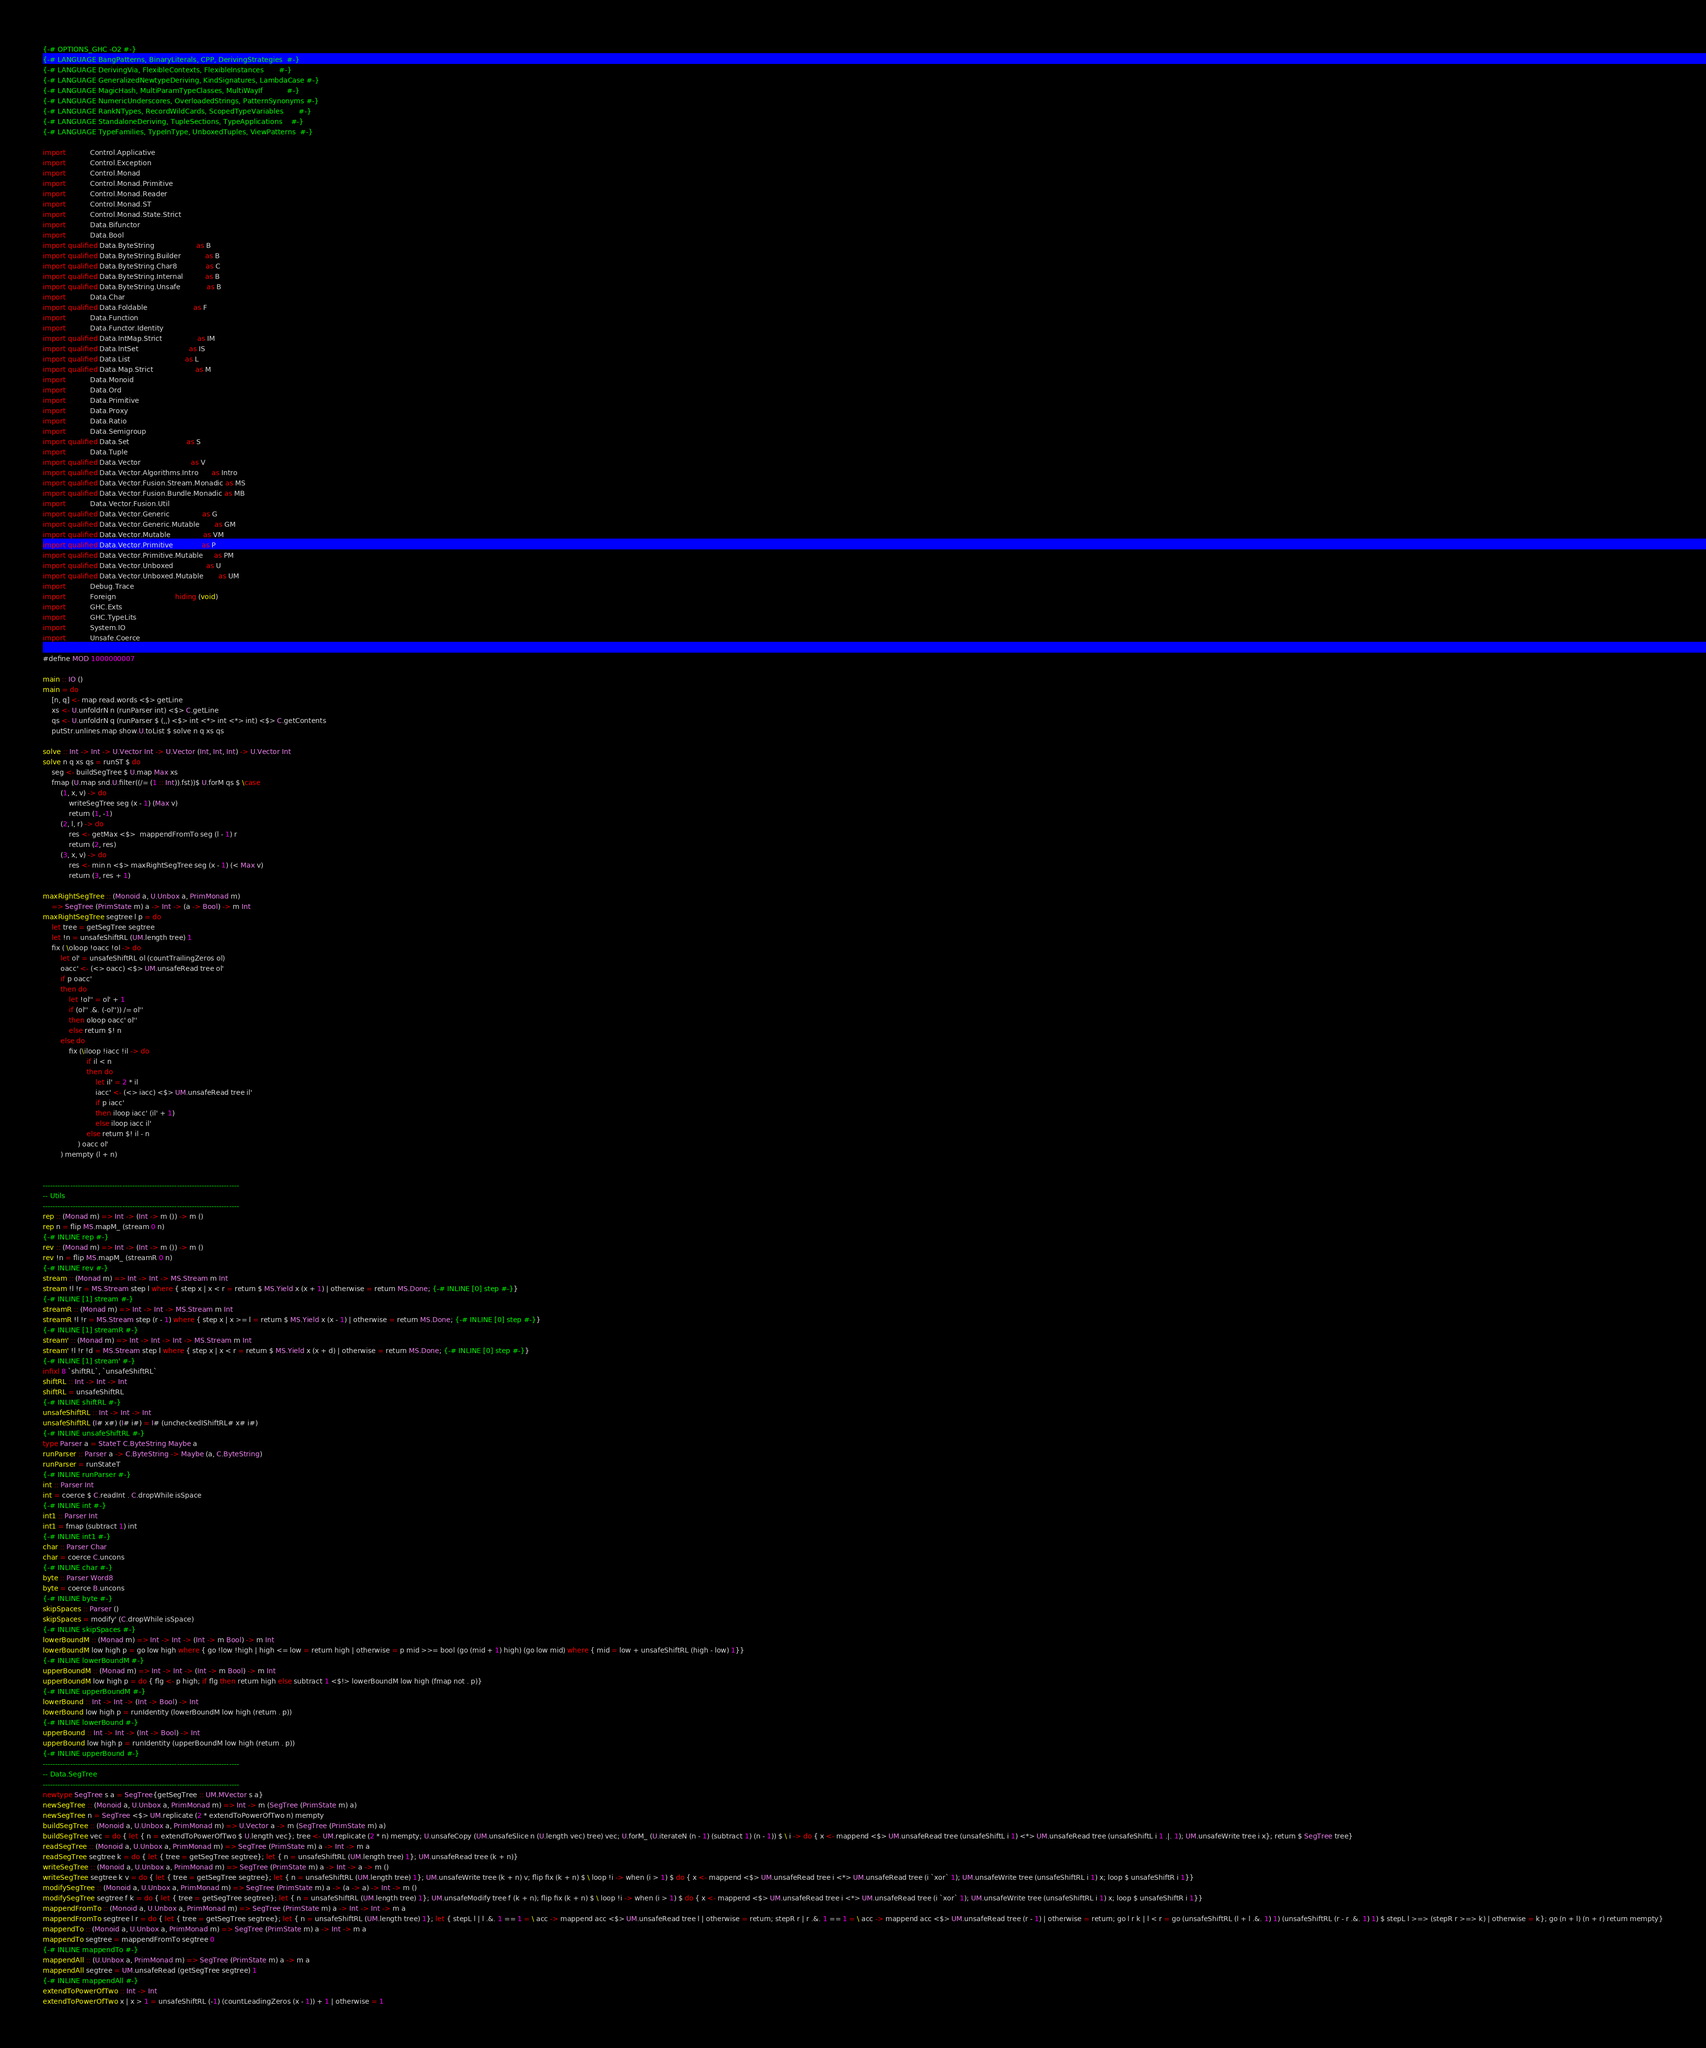Convert code to text. <code><loc_0><loc_0><loc_500><loc_500><_Haskell_>{-# OPTIONS_GHC -O2 #-}
{-# LANGUAGE BangPatterns, BinaryLiterals, CPP, DerivingStrategies  #-}
{-# LANGUAGE DerivingVia, FlexibleContexts, FlexibleInstances       #-}
{-# LANGUAGE GeneralizedNewtypeDeriving, KindSignatures, LambdaCase #-}
{-# LANGUAGE MagicHash, MultiParamTypeClasses, MultiWayIf           #-}
{-# LANGUAGE NumericUnderscores, OverloadedStrings, PatternSynonyms #-}
{-# LANGUAGE RankNTypes, RecordWildCards, ScopedTypeVariables       #-}
{-# LANGUAGE StandaloneDeriving, TupleSections, TypeApplications    #-}
{-# LANGUAGE TypeFamilies, TypeInType, UnboxedTuples, ViewPatterns  #-}

import           Control.Applicative
import           Control.Exception
import           Control.Monad
import           Control.Monad.Primitive
import           Control.Monad.Reader
import           Control.Monad.ST
import           Control.Monad.State.Strict
import           Data.Bifunctor
import           Data.Bool
import qualified Data.ByteString                   as B
import qualified Data.ByteString.Builder           as B
import qualified Data.ByteString.Char8             as C
import qualified Data.ByteString.Internal          as B
import qualified Data.ByteString.Unsafe            as B
import           Data.Char
import qualified Data.Foldable                     as F
import           Data.Function
import           Data.Functor.Identity
import qualified Data.IntMap.Strict                as IM
import qualified Data.IntSet                       as IS
import qualified Data.List                         as L
import qualified Data.Map.Strict                   as M
import           Data.Monoid
import           Data.Ord
import           Data.Primitive
import           Data.Proxy
import           Data.Ratio
import           Data.Semigroup
import qualified Data.Set                          as S
import           Data.Tuple
import qualified Data.Vector                       as V
import qualified Data.Vector.Algorithms.Intro      as Intro
import qualified Data.Vector.Fusion.Stream.Monadic as MS
import qualified Data.Vector.Fusion.Bundle.Monadic as MB
import           Data.Vector.Fusion.Util
import qualified Data.Vector.Generic               as G
import qualified Data.Vector.Generic.Mutable       as GM
import qualified Data.Vector.Mutable               as VM
import qualified Data.Vector.Primitive             as P
import qualified Data.Vector.Primitive.Mutable     as PM
import qualified Data.Vector.Unboxed               as U
import qualified Data.Vector.Unboxed.Mutable       as UM
import           Debug.Trace
import           Foreign                           hiding (void)
import           GHC.Exts
import           GHC.TypeLits
import           System.IO
import           Unsafe.Coerce

#define MOD 1000000007

main :: IO ()
main = do
    [n, q] <- map read.words <$> getLine
    xs <- U.unfoldrN n (runParser int) <$> C.getLine
    qs <- U.unfoldrN q (runParser $ (,,) <$> int <*> int <*> int) <$> C.getContents
    putStr.unlines.map show.U.toList $ solve n q xs qs

solve :: Int -> Int -> U.Vector Int -> U.Vector (Int, Int, Int) -> U.Vector Int
solve n q xs qs = runST $ do
    seg <- buildSegTree $ U.map Max xs
    fmap (U.map snd.U.filter((/= (1 :: Int)).fst))$ U.forM qs $ \case
        (1, x, v) -> do
            writeSegTree seg (x - 1) (Max v)
            return (1, -1)
        (2, l, r) -> do
            res <- getMax <$>  mappendFromTo seg (l - 1) r
            return (2, res)
        (3, x, v) -> do
            res <- min n <$> maxRightSegTree seg (x - 1) (< Max v)
            return (3, res + 1)

maxRightSegTree :: (Monoid a, U.Unbox a, PrimMonad m)
    => SegTree (PrimState m) a -> Int -> (a -> Bool) -> m Int
maxRightSegTree segtree l p = do
    let tree = getSegTree segtree
    let !n = unsafeShiftRL (UM.length tree) 1
    fix ( \oloop !oacc !ol -> do
        let ol' = unsafeShiftRL ol (countTrailingZeros ol)
        oacc' <- (<> oacc) <$> UM.unsafeRead tree ol'
        if p oacc'
        then do
            let !ol'' = ol' + 1
            if (ol'' .&. (-ol'')) /= ol''
            then oloop oacc' ol''
            else return $! n
        else do
            fix (\iloop !iacc !il -> do
                    if il < n
                    then do
                        let il' = 2 * il
                        iacc' <- (<> iacc) <$> UM.unsafeRead tree il'
                        if p iacc'
                        then iloop iacc' (il' + 1)
                        else iloop iacc il'
                    else return $! il - n
                ) oacc ol'
        ) mempty (l + n)


-------------------------------------------------------------------------------
-- Utils
-------------------------------------------------------------------------------
rep :: (Monad m) => Int -> (Int -> m ()) -> m ()
rep n = flip MS.mapM_ (stream 0 n)
{-# INLINE rep #-}
rev :: (Monad m) => Int -> (Int -> m ()) -> m ()
rev !n = flip MS.mapM_ (streamR 0 n)
{-# INLINE rev #-}
stream :: (Monad m) => Int -> Int -> MS.Stream m Int
stream !l !r = MS.Stream step l where { step x | x < r = return $ MS.Yield x (x + 1) | otherwise = return MS.Done; {-# INLINE [0] step #-}}
{-# INLINE [1] stream #-}
streamR :: (Monad m) => Int -> Int -> MS.Stream m Int
streamR !l !r = MS.Stream step (r - 1) where { step x | x >= l = return $ MS.Yield x (x - 1) | otherwise = return MS.Done; {-# INLINE [0] step #-}}
{-# INLINE [1] streamR #-}
stream' :: (Monad m) => Int -> Int -> Int -> MS.Stream m Int
stream' !l !r !d = MS.Stream step l where { step x | x < r = return $ MS.Yield x (x + d) | otherwise = return MS.Done; {-# INLINE [0] step #-}}
{-# INLINE [1] stream' #-}
infixl 8 `shiftRL`, `unsafeShiftRL`
shiftRL :: Int -> Int -> Int
shiftRL = unsafeShiftRL
{-# INLINE shiftRL #-}
unsafeShiftRL :: Int -> Int -> Int
unsafeShiftRL (I# x#) (I# i#) = I# (uncheckedIShiftRL# x# i#)
{-# INLINE unsafeShiftRL #-}
type Parser a = StateT C.ByteString Maybe a
runParser :: Parser a -> C.ByteString -> Maybe (a, C.ByteString)
runParser = runStateT
{-# INLINE runParser #-}
int :: Parser Int
int = coerce $ C.readInt . C.dropWhile isSpace
{-# INLINE int #-}
int1 :: Parser Int
int1 = fmap (subtract 1) int
{-# INLINE int1 #-}
char :: Parser Char
char = coerce C.uncons
{-# INLINE char #-}
byte :: Parser Word8
byte = coerce B.uncons
{-# INLINE byte #-}
skipSpaces :: Parser ()
skipSpaces = modify' (C.dropWhile isSpace)
{-# INLINE skipSpaces #-}
lowerBoundM :: (Monad m) => Int -> Int -> (Int -> m Bool) -> m Int
lowerBoundM low high p = go low high where { go !low !high | high <= low = return high | otherwise = p mid >>= bool (go (mid + 1) high) (go low mid) where { mid = low + unsafeShiftRL (high - low) 1}}
{-# INLINE lowerBoundM #-}
upperBoundM :: (Monad m) => Int -> Int -> (Int -> m Bool) -> m Int
upperBoundM low high p = do { flg <- p high; if flg then return high else subtract 1 <$!> lowerBoundM low high (fmap not . p)}
{-# INLINE upperBoundM #-}
lowerBound :: Int -> Int -> (Int -> Bool) -> Int
lowerBound low high p = runIdentity (lowerBoundM low high (return . p))
{-# INLINE lowerBound #-}
upperBound :: Int -> Int -> (Int -> Bool) -> Int
upperBound low high p = runIdentity (upperBoundM low high (return . p))
{-# INLINE upperBound #-}
-------------------------------------------------------------------------------
-- Data.SegTree
-------------------------------------------------------------------------------
newtype SegTree s a = SegTree{getSegTree :: UM.MVector s a}
newSegTree :: (Monoid a, U.Unbox a, PrimMonad m) => Int -> m (SegTree (PrimState m) a)
newSegTree n = SegTree <$> UM.replicate (2 * extendToPowerOfTwo n) mempty
buildSegTree :: (Monoid a, U.Unbox a, PrimMonad m) => U.Vector a -> m (SegTree (PrimState m) a)
buildSegTree vec = do { let { n = extendToPowerOfTwo $ U.length vec}; tree <- UM.replicate (2 * n) mempty; U.unsafeCopy (UM.unsafeSlice n (U.length vec) tree) vec; U.forM_ (U.iterateN (n - 1) (subtract 1) (n - 1)) $ \ i -> do { x <- mappend <$> UM.unsafeRead tree (unsafeShiftL i 1) <*> UM.unsafeRead tree (unsafeShiftL i 1 .|. 1); UM.unsafeWrite tree i x}; return $ SegTree tree}
readSegTree :: (Monoid a, U.Unbox a, PrimMonad m) => SegTree (PrimState m) a -> Int -> m a
readSegTree segtree k = do { let { tree = getSegTree segtree}; let { n = unsafeShiftRL (UM.length tree) 1}; UM.unsafeRead tree (k + n)}
writeSegTree :: (Monoid a, U.Unbox a, PrimMonad m) => SegTree (PrimState m) a -> Int -> a -> m ()
writeSegTree segtree k v = do { let { tree = getSegTree segtree}; let { n = unsafeShiftRL (UM.length tree) 1}; UM.unsafeWrite tree (k + n) v; flip fix (k + n) $ \ loop !i -> when (i > 1) $ do { x <- mappend <$> UM.unsafeRead tree i <*> UM.unsafeRead tree (i `xor` 1); UM.unsafeWrite tree (unsafeShiftRL i 1) x; loop $ unsafeShiftR i 1}}
modifySegTree :: (Monoid a, U.Unbox a, PrimMonad m) => SegTree (PrimState m) a -> (a -> a) -> Int -> m ()
modifySegTree segtree f k = do { let { tree = getSegTree segtree}; let { n = unsafeShiftRL (UM.length tree) 1}; UM.unsafeModify tree f (k + n); flip fix (k + n) $ \ loop !i -> when (i > 1) $ do { x <- mappend <$> UM.unsafeRead tree i <*> UM.unsafeRead tree (i `xor` 1); UM.unsafeWrite tree (unsafeShiftRL i 1) x; loop $ unsafeShiftR i 1}}
mappendFromTo :: (Monoid a, U.Unbox a, PrimMonad m) => SegTree (PrimState m) a -> Int -> Int -> m a
mappendFromTo segtree l r = do { let { tree = getSegTree segtree}; let { n = unsafeShiftRL (UM.length tree) 1}; let { stepL l | l .&. 1 == 1 = \ acc -> mappend acc <$> UM.unsafeRead tree l | otherwise = return; stepR r | r .&. 1 == 1 = \ acc -> mappend acc <$> UM.unsafeRead tree (r - 1) | otherwise = return; go l r k | l < r = go (unsafeShiftRL (l + l .&. 1) 1) (unsafeShiftRL (r - r .&. 1) 1) $ stepL l >=> (stepR r >=> k) | otherwise = k}; go (n + l) (n + r) return mempty}
mappendTo :: (Monoid a, U.Unbox a, PrimMonad m) => SegTree (PrimState m) a -> Int -> m a
mappendTo segtree = mappendFromTo segtree 0
{-# INLINE mappendTo #-}
mappendAll :: (U.Unbox a, PrimMonad m) => SegTree (PrimState m) a -> m a
mappendAll segtree = UM.unsafeRead (getSegTree segtree) 1
{-# INLINE mappendAll #-}
extendToPowerOfTwo :: Int -> Int
extendToPowerOfTwo x | x > 1 = unsafeShiftRL (-1) (countLeadingZeros (x - 1)) + 1 | otherwise = 1
</code> 